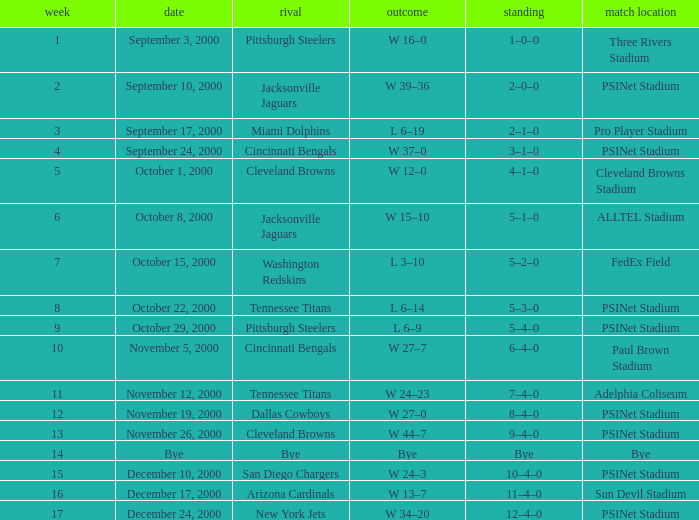What's the result at psinet stadium when the cincinnati bengals are the opponent? W 37–0. 